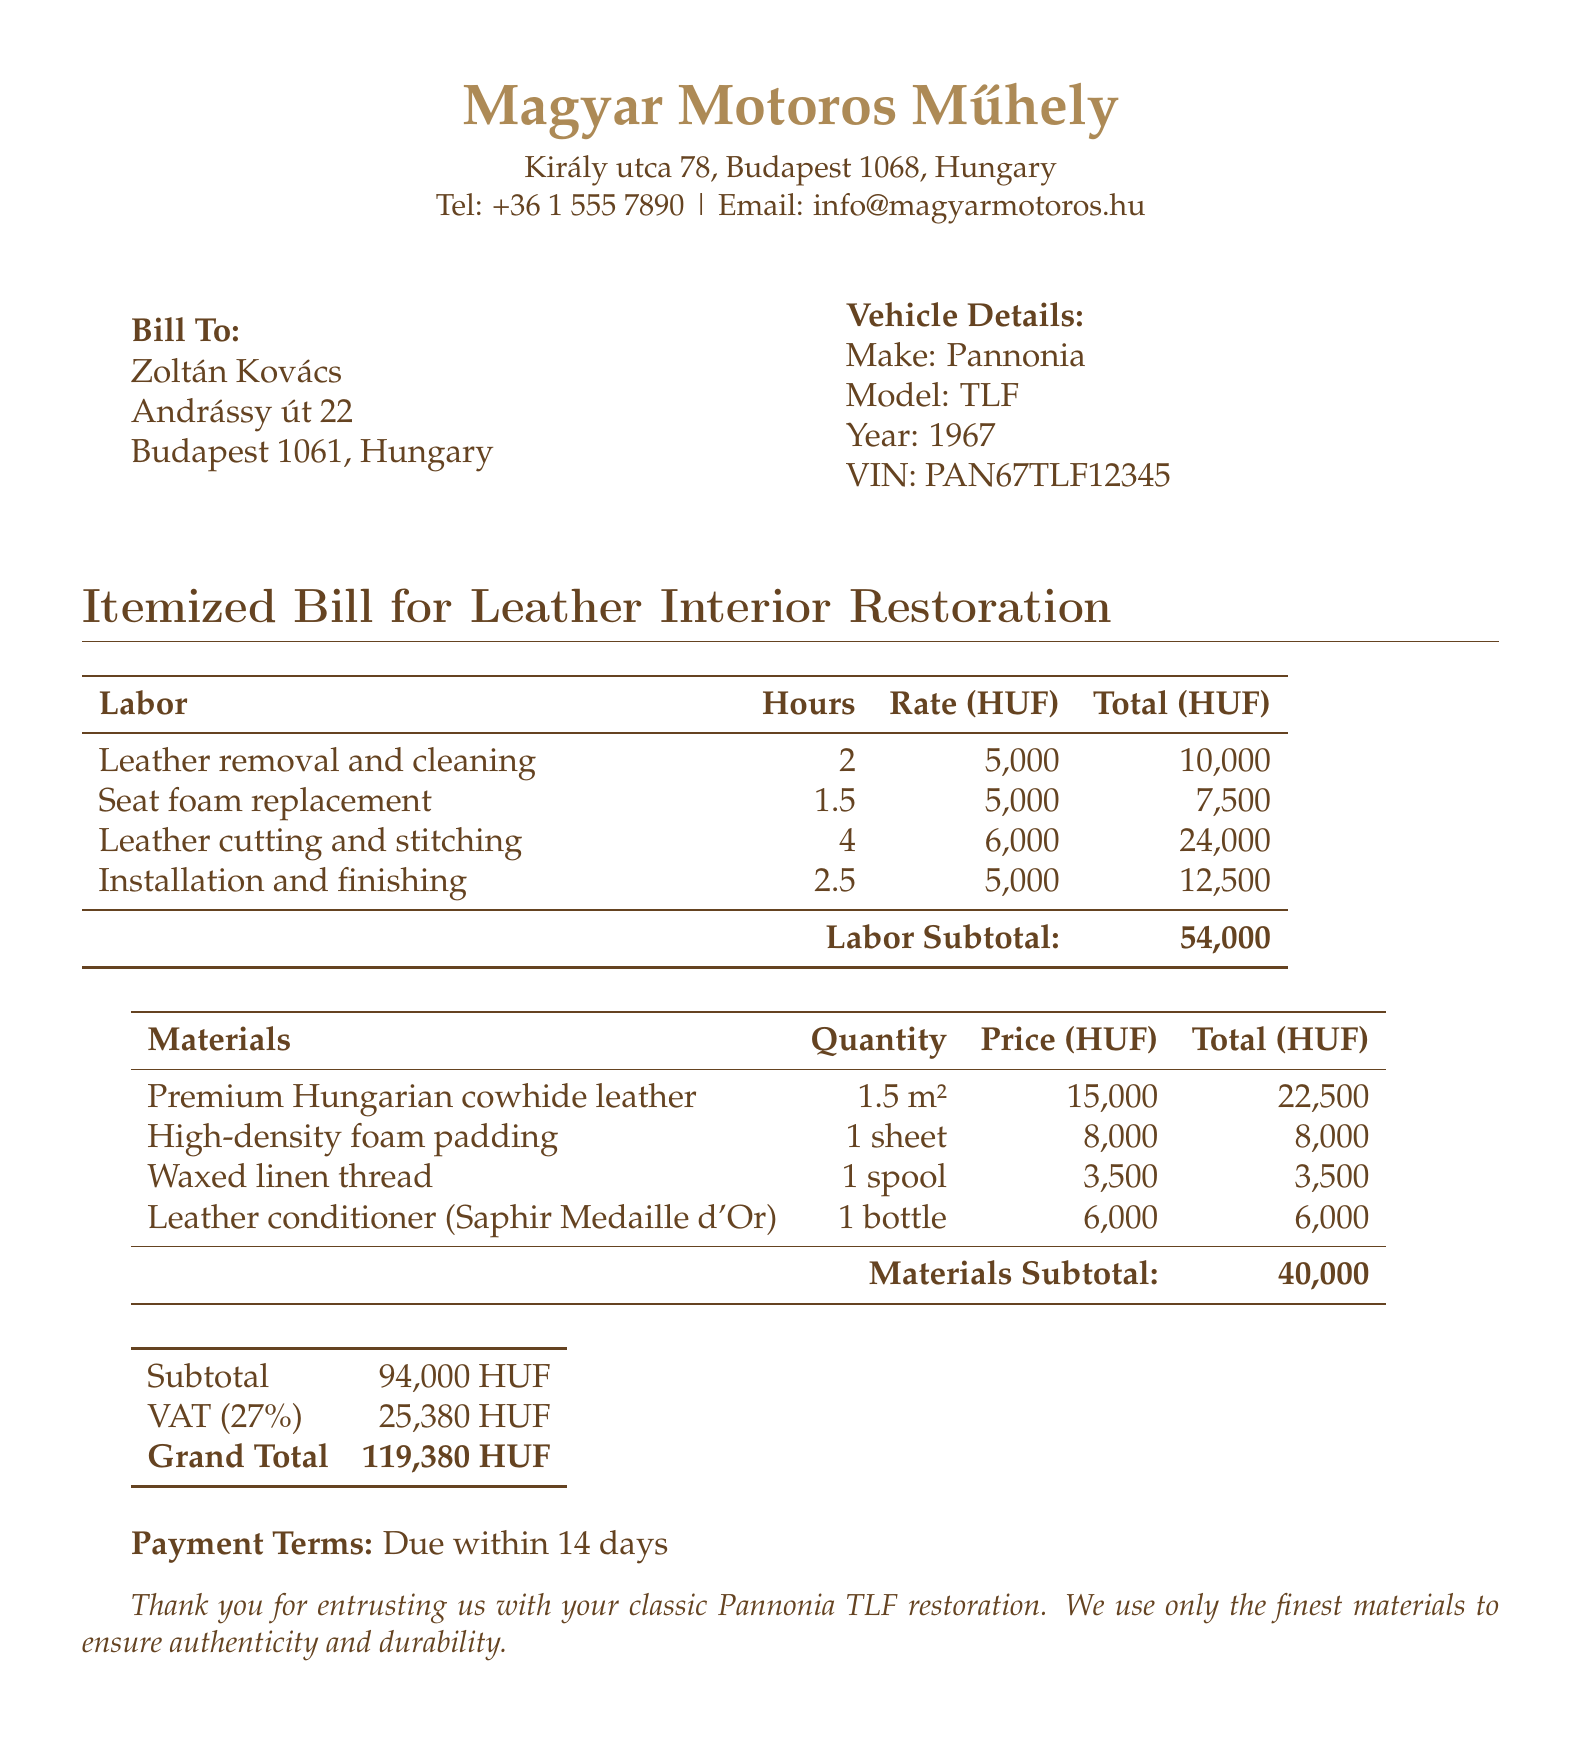What is the total labor cost? The total labor cost can be found in the labor subtotal section of the document, which is 54,000 HUF.
Answer: 54,000 HUF What materials are listed? The materials section lists four items: Premium Hungarian cowhide leather, high-density foam padding, waxed linen thread, and leather conditioner.
Answer: Four items What is the VAT percentage applied? The VAT percentage applied to the subtotal can be found in the document, which is stated as 27%.
Answer: 27% How many hours were spent on leather removal and cleaning? The number of hours for leather removal and cleaning is found in the labor table, which states 2 hours.
Answer: 2 hours What is the total amount due? The grand total is clearly indicated at the bottom of the document as 119,380 HUF.
Answer: 119,380 HUF What is the price of a bottle of leather conditioner? The price of a bottle of leather conditioner is specified in the materials section, which is 6,000 HUF.
Answer: 6,000 HUF Who is the bill addressed to? The document indicates the bill is addressed to Zoltán Kovács.
Answer: Zoltán Kovács What is the payment term for the bill? The payment term is stated in the document as due within 14 days.
Answer: Due within 14 days What type of motorcycle is being restored? The document specifies that the motorcycle being restored is a Pannonia TLF.
Answer: Pannonia TLF 